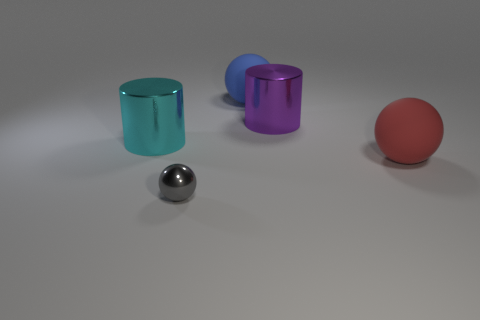Add 2 purple cylinders. How many objects exist? 7 Subtract all balls. How many objects are left? 2 Add 4 gray metallic objects. How many gray metallic objects are left? 5 Add 1 purple metallic things. How many purple metallic things exist? 2 Subtract 0 blue cubes. How many objects are left? 5 Subtract all purple metal cylinders. Subtract all metal things. How many objects are left? 1 